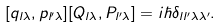Convert formula to latex. <formula><loc_0><loc_0><loc_500><loc_500>[ q _ { l \lambda } , p _ { l ^ { \prime } \lambda } ] [ Q _ { l \lambda } , P _ { l ^ { \prime } \lambda } ] = i \hbar { \delta } _ { l l ^ { \prime } \lambda \lambda ^ { \prime } } .</formula> 